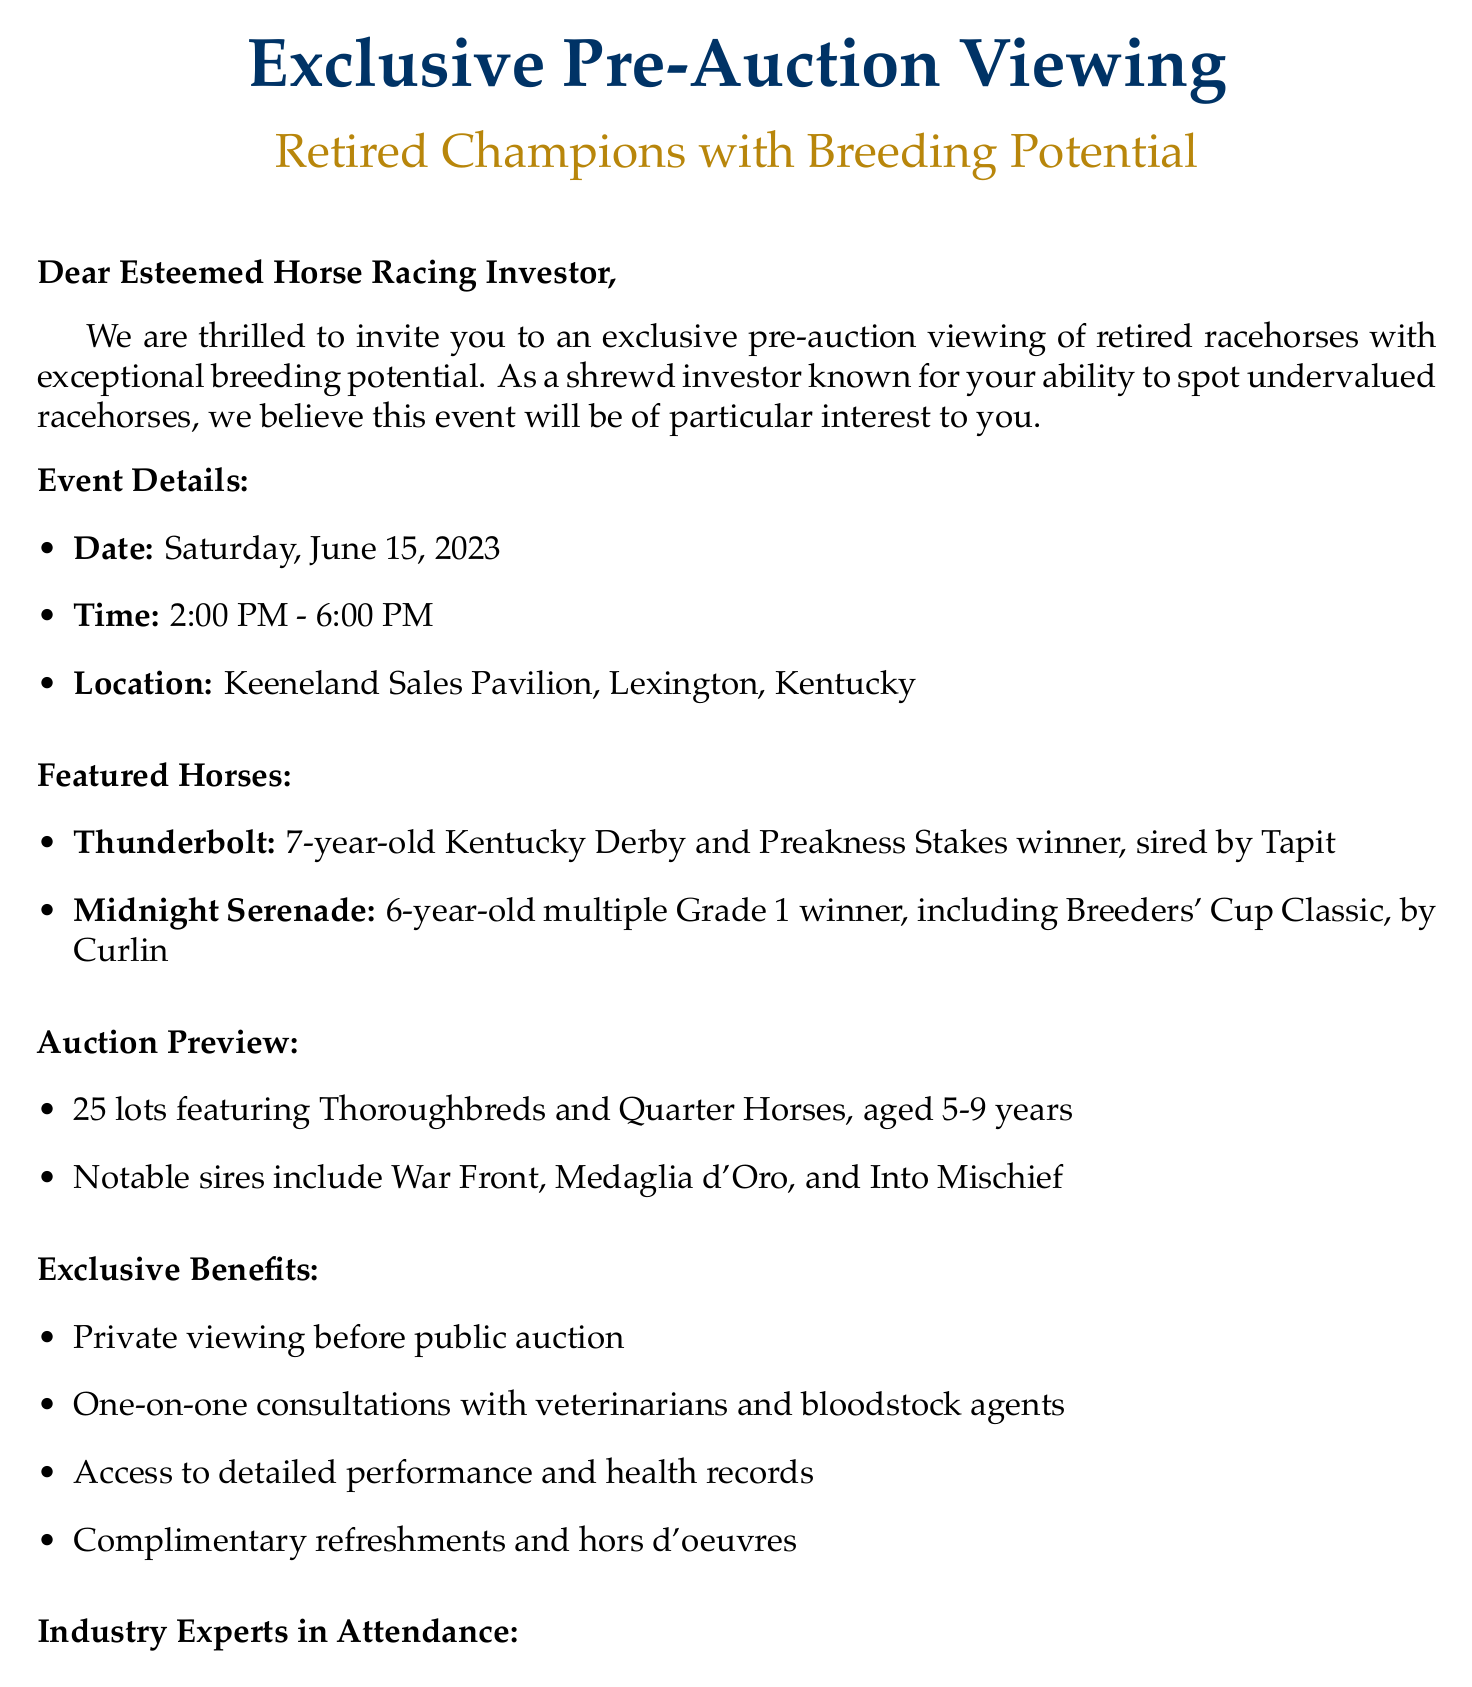What is the date of the event? The date of the event is explicitly mentioned in the document.
Answer: Saturday, June 15, 2023 What are the names of the featured horses? The document lists two featured horses, specifying their names and notable achievements.
Answer: Thunderbolt, Midnight Serenade How many lots will be presented at the auction? The total number of lots is specified as part of the auction preview.
Answer: 25 Who should be contacted for RSVPs? The RSVP instructions provide clear contact information for the event.
Answer: Sarah Thompson What is the age range of the horses at the auction? The auction preview outlines the age range of the horses.
Answer: 5-9 years old What notable sires are mentioned in the document? The auction preview includes a list of notable sires.
Answer: War Front, Medaglia d'Oro, Into Mischief What is one exclusive benefit offered at the event? The document lists several exclusive benefits, allowing for a specific example to be selected.
Answer: Private viewing of horses before public auction Who is one of the industry experts attending? The document names several industry experts attending the event.
Answer: Tom Durkin 